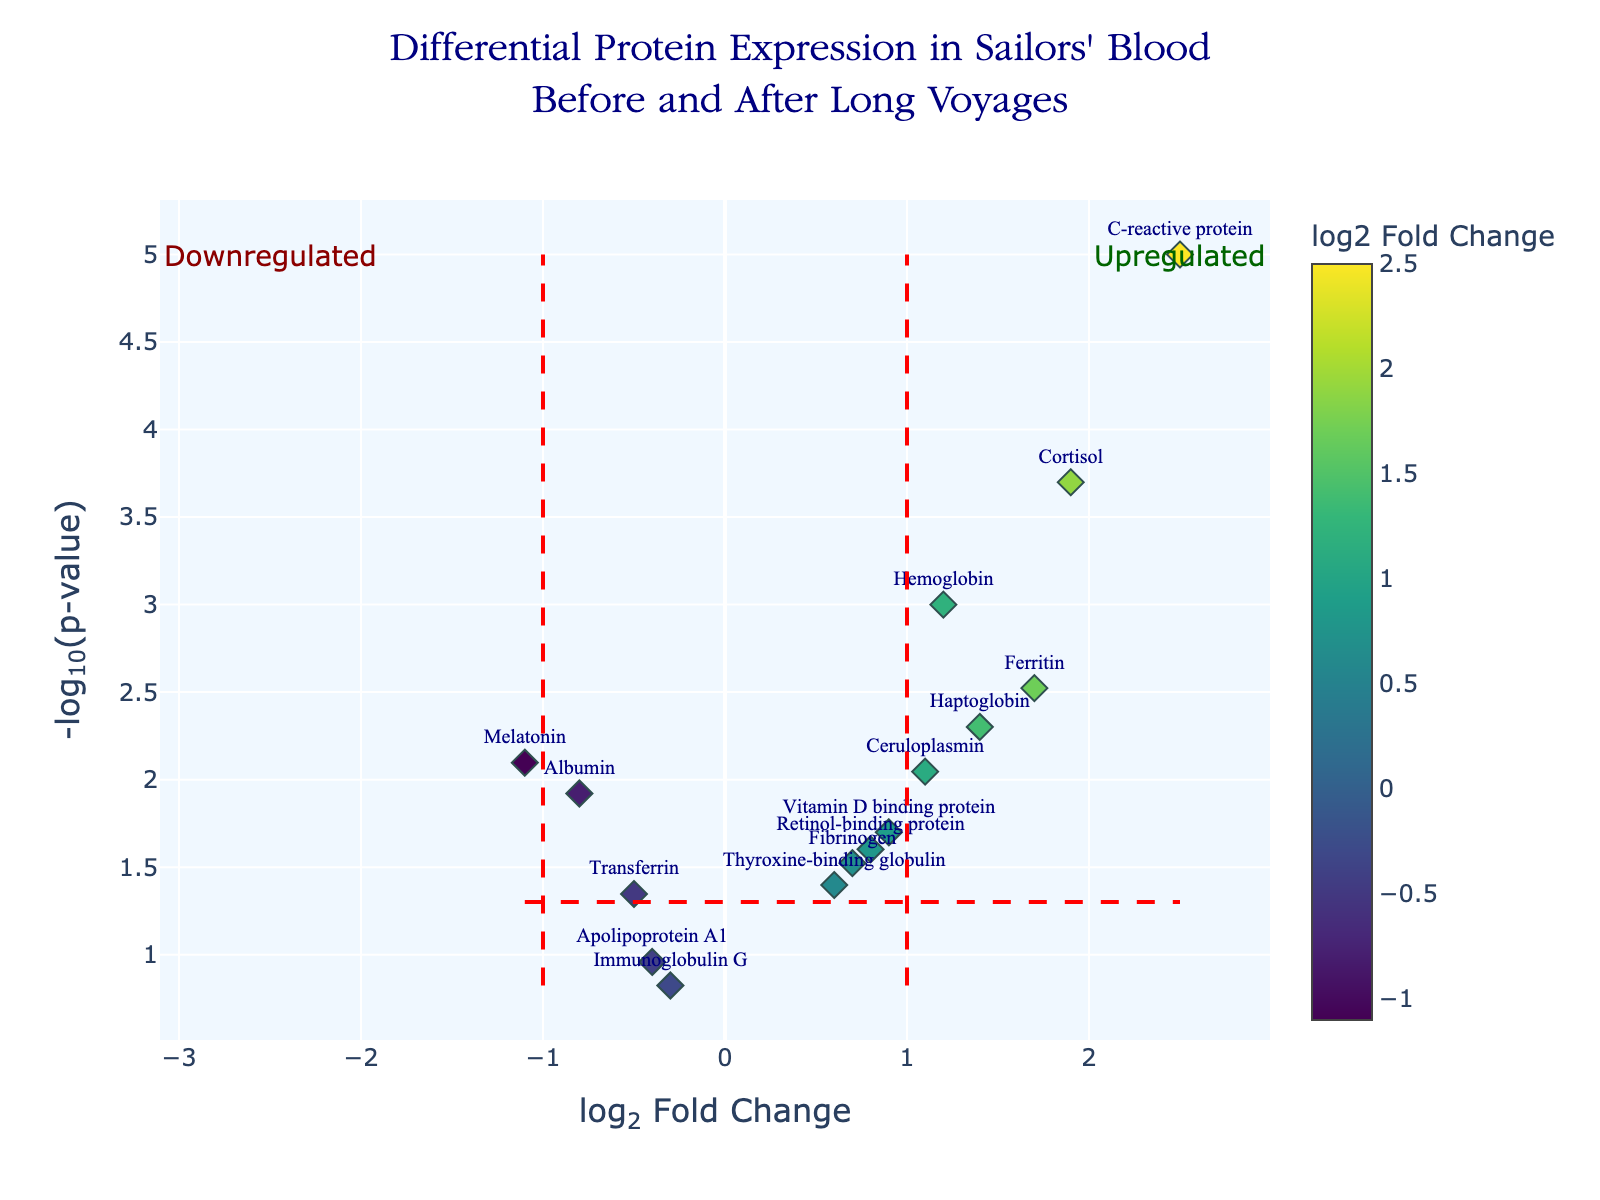What is the title of the plot? The title of the plot is located at the top of the figure in a larger font, setting the context for what the data represents. It reads "Differential Protein Expression in Sailors' Blood Before and After Long Voyages".
Answer: "Differential Protein Expression in Sailors' Blood Before and After Long Voyages" Which protein has the highest log2 fold change? The highest log2 fold change corresponds to the point furthest to the right on the x-axis. From the plot, this is C-reactive protein with a log2 fold change of 2.5.
Answer: C-reactive protein What is the log2 fold change for Melatonin? Locate the text label for Melatonin on the plot and read its position on the x-axis. The log2 fold change for Melatonin is -1.1.
Answer: -1.1 Which proteins are upregulated? Proteins are upregulated if their log2 fold change is greater than 0. From the plot, these proteins are Hemoglobin, C-reactive protein, Ferritin, Cortisol, Vitamin D binding protein, Haptoglobin, Fibrinogen, Thyroxine-binding globulin, and Ceruloplasmin.
Answer: Hemoglobin, C-reactive protein, Ferritin, Cortisol, Vitamin D binding protein, Haptoglobin, Fibrinogen, Thyroxine-binding globulin, Ceruloplasmin How many proteins have a log2 fold change between -1 and 1? Proteins with a log2 fold change between -1 and 1 are within two vertical red dashed lines on the plot. Count the points within this range. There are five proteins: Albumin, Transferrin, Vitamin D binding protein, Fibrinogen, and Retinol-binding protein.
Answer: Five Which protein has the most significant p-value? The most significant p-value will have the highest -log10(p-value). Locate the highest point on the y-axis. From the plot, this is C-reactive protein with a -log10(p-value) of 5.
Answer: C-reactive protein Are there more upregulated or downregulated proteins? Upregulated proteins have positive log2 fold change, while downregulated have negative. Count both categories and compare. There are 9 upregulated proteins and 6 downregulated ones.
Answer: Upregulated What is the log2 fold change and p-value for Hemoglobin? Locate Hemoglobin on the plot, check its position along the x-axis for log2 fold change and along the y-axis for the -log10(p-value) to find its p-value. Hemoglobin has a log2 fold change of 1.2 and a p-value of 0.001.
Answer: Log2 fold change: 1.2, p-value: 0.001 Which protein is downregulated but not significant at the 0.05 threshold? Downregulated proteins have a negative log2 fold change, and non-significant ones have -log10(p-value) below the red horizontal line. From the plot, Immunoglobulin G is the downregulated protein that is not significant.
Answer: Immunoglobulin G What is the p-value threshold for significance on this plot? The significance threshold line is a red horizontal dashed line intersecting the y-axis. Its exact y-value is -log10(0.05). This corresponds to 1.301.
Answer: 0.05 